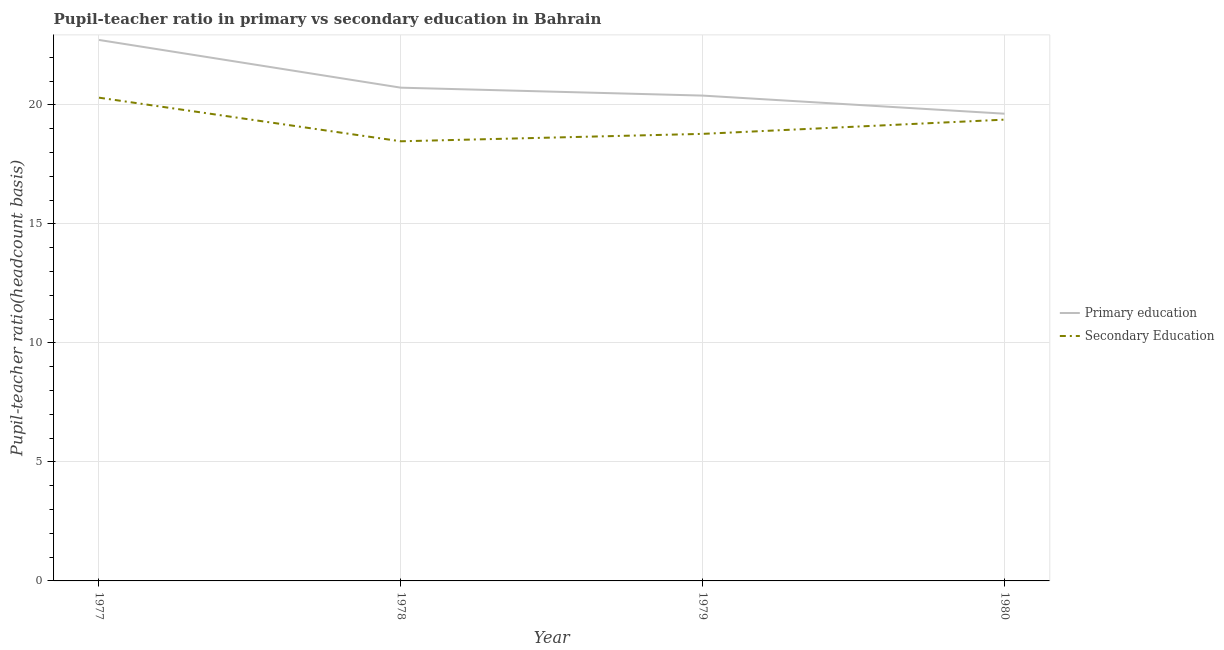How many different coloured lines are there?
Provide a succinct answer. 2. Does the line corresponding to pupil-teacher ratio in primary education intersect with the line corresponding to pupil teacher ratio on secondary education?
Offer a very short reply. No. Is the number of lines equal to the number of legend labels?
Provide a short and direct response. Yes. What is the pupil-teacher ratio in primary education in 1978?
Provide a succinct answer. 20.73. Across all years, what is the maximum pupil teacher ratio on secondary education?
Your response must be concise. 20.31. Across all years, what is the minimum pupil teacher ratio on secondary education?
Provide a short and direct response. 18.47. In which year was the pupil teacher ratio on secondary education maximum?
Provide a short and direct response. 1977. In which year was the pupil teacher ratio on secondary education minimum?
Your response must be concise. 1978. What is the total pupil-teacher ratio in primary education in the graph?
Your answer should be compact. 83.49. What is the difference between the pupil-teacher ratio in primary education in 1978 and that in 1980?
Provide a succinct answer. 1.09. What is the difference between the pupil teacher ratio on secondary education in 1980 and the pupil-teacher ratio in primary education in 1978?
Provide a short and direct response. -1.34. What is the average pupil-teacher ratio in primary education per year?
Your answer should be compact. 20.87. In the year 1977, what is the difference between the pupil teacher ratio on secondary education and pupil-teacher ratio in primary education?
Make the answer very short. -2.43. What is the ratio of the pupil teacher ratio on secondary education in 1977 to that in 1980?
Offer a very short reply. 1.05. Is the pupil teacher ratio on secondary education in 1977 less than that in 1979?
Your response must be concise. No. Is the difference between the pupil-teacher ratio in primary education in 1979 and 1980 greater than the difference between the pupil teacher ratio on secondary education in 1979 and 1980?
Ensure brevity in your answer.  Yes. What is the difference between the highest and the second highest pupil-teacher ratio in primary education?
Make the answer very short. 2.01. What is the difference between the highest and the lowest pupil-teacher ratio in primary education?
Provide a succinct answer. 3.1. In how many years, is the pupil-teacher ratio in primary education greater than the average pupil-teacher ratio in primary education taken over all years?
Your answer should be compact. 1. Does the pupil teacher ratio on secondary education monotonically increase over the years?
Offer a terse response. No. Is the pupil teacher ratio on secondary education strictly less than the pupil-teacher ratio in primary education over the years?
Provide a short and direct response. Yes. How many lines are there?
Your answer should be compact. 2. Are the values on the major ticks of Y-axis written in scientific E-notation?
Offer a very short reply. No. Does the graph contain any zero values?
Keep it short and to the point. No. How are the legend labels stacked?
Provide a succinct answer. Vertical. What is the title of the graph?
Offer a very short reply. Pupil-teacher ratio in primary vs secondary education in Bahrain. What is the label or title of the Y-axis?
Provide a short and direct response. Pupil-teacher ratio(headcount basis). What is the Pupil-teacher ratio(headcount basis) of Primary education in 1977?
Give a very brief answer. 22.73. What is the Pupil-teacher ratio(headcount basis) of Secondary Education in 1977?
Keep it short and to the point. 20.31. What is the Pupil-teacher ratio(headcount basis) of Primary education in 1978?
Make the answer very short. 20.73. What is the Pupil-teacher ratio(headcount basis) in Secondary Education in 1978?
Make the answer very short. 18.47. What is the Pupil-teacher ratio(headcount basis) in Primary education in 1979?
Keep it short and to the point. 20.39. What is the Pupil-teacher ratio(headcount basis) of Secondary Education in 1979?
Offer a terse response. 18.79. What is the Pupil-teacher ratio(headcount basis) in Primary education in 1980?
Ensure brevity in your answer.  19.63. What is the Pupil-teacher ratio(headcount basis) in Secondary Education in 1980?
Make the answer very short. 19.38. Across all years, what is the maximum Pupil-teacher ratio(headcount basis) of Primary education?
Provide a short and direct response. 22.73. Across all years, what is the maximum Pupil-teacher ratio(headcount basis) of Secondary Education?
Offer a terse response. 20.31. Across all years, what is the minimum Pupil-teacher ratio(headcount basis) in Primary education?
Your response must be concise. 19.63. Across all years, what is the minimum Pupil-teacher ratio(headcount basis) in Secondary Education?
Provide a succinct answer. 18.47. What is the total Pupil-teacher ratio(headcount basis) in Primary education in the graph?
Your response must be concise. 83.49. What is the total Pupil-teacher ratio(headcount basis) of Secondary Education in the graph?
Offer a terse response. 76.95. What is the difference between the Pupil-teacher ratio(headcount basis) in Primary education in 1977 and that in 1978?
Your answer should be very brief. 2.01. What is the difference between the Pupil-teacher ratio(headcount basis) in Secondary Education in 1977 and that in 1978?
Offer a very short reply. 1.83. What is the difference between the Pupil-teacher ratio(headcount basis) in Primary education in 1977 and that in 1979?
Your answer should be very brief. 2.34. What is the difference between the Pupil-teacher ratio(headcount basis) in Secondary Education in 1977 and that in 1979?
Ensure brevity in your answer.  1.52. What is the difference between the Pupil-teacher ratio(headcount basis) of Primary education in 1977 and that in 1980?
Provide a short and direct response. 3.1. What is the difference between the Pupil-teacher ratio(headcount basis) of Primary education in 1978 and that in 1979?
Your answer should be very brief. 0.33. What is the difference between the Pupil-teacher ratio(headcount basis) of Secondary Education in 1978 and that in 1979?
Provide a short and direct response. -0.31. What is the difference between the Pupil-teacher ratio(headcount basis) of Primary education in 1978 and that in 1980?
Provide a succinct answer. 1.09. What is the difference between the Pupil-teacher ratio(headcount basis) in Secondary Education in 1978 and that in 1980?
Your response must be concise. -0.91. What is the difference between the Pupil-teacher ratio(headcount basis) of Primary education in 1979 and that in 1980?
Keep it short and to the point. 0.76. What is the difference between the Pupil-teacher ratio(headcount basis) of Secondary Education in 1979 and that in 1980?
Give a very brief answer. -0.6. What is the difference between the Pupil-teacher ratio(headcount basis) of Primary education in 1977 and the Pupil-teacher ratio(headcount basis) of Secondary Education in 1978?
Your answer should be very brief. 4.26. What is the difference between the Pupil-teacher ratio(headcount basis) in Primary education in 1977 and the Pupil-teacher ratio(headcount basis) in Secondary Education in 1979?
Provide a short and direct response. 3.95. What is the difference between the Pupil-teacher ratio(headcount basis) of Primary education in 1977 and the Pupil-teacher ratio(headcount basis) of Secondary Education in 1980?
Your answer should be compact. 3.35. What is the difference between the Pupil-teacher ratio(headcount basis) in Primary education in 1978 and the Pupil-teacher ratio(headcount basis) in Secondary Education in 1979?
Provide a short and direct response. 1.94. What is the difference between the Pupil-teacher ratio(headcount basis) in Primary education in 1978 and the Pupil-teacher ratio(headcount basis) in Secondary Education in 1980?
Provide a short and direct response. 1.34. What is the difference between the Pupil-teacher ratio(headcount basis) in Primary education in 1979 and the Pupil-teacher ratio(headcount basis) in Secondary Education in 1980?
Your response must be concise. 1.01. What is the average Pupil-teacher ratio(headcount basis) in Primary education per year?
Ensure brevity in your answer.  20.87. What is the average Pupil-teacher ratio(headcount basis) of Secondary Education per year?
Make the answer very short. 19.24. In the year 1977, what is the difference between the Pupil-teacher ratio(headcount basis) of Primary education and Pupil-teacher ratio(headcount basis) of Secondary Education?
Offer a very short reply. 2.43. In the year 1978, what is the difference between the Pupil-teacher ratio(headcount basis) of Primary education and Pupil-teacher ratio(headcount basis) of Secondary Education?
Ensure brevity in your answer.  2.25. In the year 1979, what is the difference between the Pupil-teacher ratio(headcount basis) in Primary education and Pupil-teacher ratio(headcount basis) in Secondary Education?
Your answer should be very brief. 1.61. In the year 1980, what is the difference between the Pupil-teacher ratio(headcount basis) in Primary education and Pupil-teacher ratio(headcount basis) in Secondary Education?
Offer a terse response. 0.25. What is the ratio of the Pupil-teacher ratio(headcount basis) in Primary education in 1977 to that in 1978?
Give a very brief answer. 1.1. What is the ratio of the Pupil-teacher ratio(headcount basis) of Secondary Education in 1977 to that in 1978?
Offer a terse response. 1.1. What is the ratio of the Pupil-teacher ratio(headcount basis) in Primary education in 1977 to that in 1979?
Provide a short and direct response. 1.11. What is the ratio of the Pupil-teacher ratio(headcount basis) of Secondary Education in 1977 to that in 1979?
Offer a terse response. 1.08. What is the ratio of the Pupil-teacher ratio(headcount basis) in Primary education in 1977 to that in 1980?
Your response must be concise. 1.16. What is the ratio of the Pupil-teacher ratio(headcount basis) of Secondary Education in 1977 to that in 1980?
Make the answer very short. 1.05. What is the ratio of the Pupil-teacher ratio(headcount basis) of Primary education in 1978 to that in 1979?
Your answer should be compact. 1.02. What is the ratio of the Pupil-teacher ratio(headcount basis) of Secondary Education in 1978 to that in 1979?
Give a very brief answer. 0.98. What is the ratio of the Pupil-teacher ratio(headcount basis) in Primary education in 1978 to that in 1980?
Your answer should be very brief. 1.06. What is the ratio of the Pupil-teacher ratio(headcount basis) in Secondary Education in 1978 to that in 1980?
Offer a very short reply. 0.95. What is the ratio of the Pupil-teacher ratio(headcount basis) in Primary education in 1979 to that in 1980?
Your answer should be very brief. 1.04. What is the ratio of the Pupil-teacher ratio(headcount basis) in Secondary Education in 1979 to that in 1980?
Make the answer very short. 0.97. What is the difference between the highest and the second highest Pupil-teacher ratio(headcount basis) of Primary education?
Provide a succinct answer. 2.01. What is the difference between the highest and the second highest Pupil-teacher ratio(headcount basis) of Secondary Education?
Your answer should be very brief. 0.92. What is the difference between the highest and the lowest Pupil-teacher ratio(headcount basis) in Primary education?
Give a very brief answer. 3.1. What is the difference between the highest and the lowest Pupil-teacher ratio(headcount basis) in Secondary Education?
Provide a succinct answer. 1.83. 